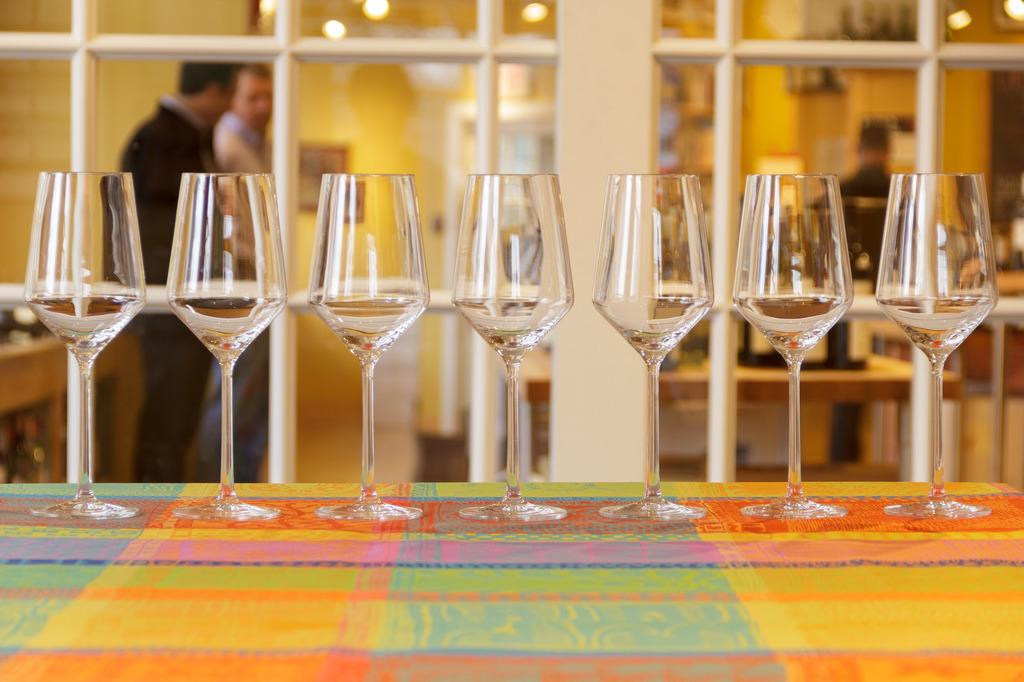What objects are on the table in the image? There are glasses on the table in the image. What is covering the table in the image? There is a colorful cloth on the table in the image. Can you describe the people visible in the image? There are two persons visible at the back side of the image. What type of pin is the queen wearing in the image? There is no queen or pin present in the image. What is the governor's opinion on the matter discussed in the image? There is no governor or discussion present in the image. 